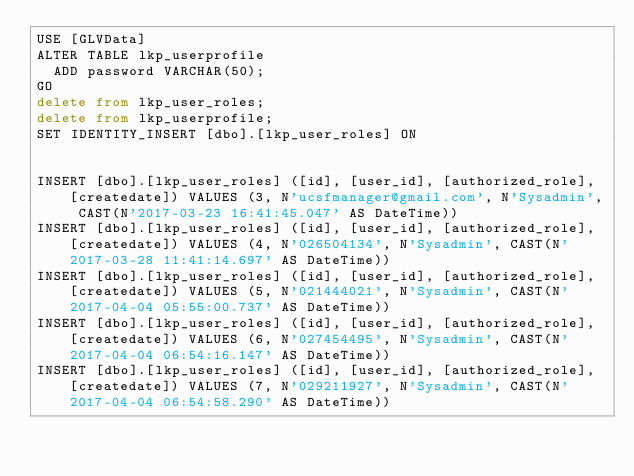<code> <loc_0><loc_0><loc_500><loc_500><_SQL_>USE [GLVData]
ALTER TABLE lkp_userprofile
  ADD password VARCHAR(50);
GO
delete from lkp_user_roles;
delete from lkp_userprofile;
SET IDENTITY_INSERT [dbo].[lkp_user_roles] ON 


INSERT [dbo].[lkp_user_roles] ([id], [user_id], [authorized_role], [createdate]) VALUES (3, N'ucsfmanager@gmail.com', N'Sysadmin', CAST(N'2017-03-23 16:41:45.047' AS DateTime))
INSERT [dbo].[lkp_user_roles] ([id], [user_id], [authorized_role], [createdate]) VALUES (4, N'026504134', N'Sysadmin', CAST(N'2017-03-28 11:41:14.697' AS DateTime))
INSERT [dbo].[lkp_user_roles] ([id], [user_id], [authorized_role], [createdate]) VALUES (5, N'021444021', N'Sysadmin', CAST(N'2017-04-04 05:55:00.737' AS DateTime))
INSERT [dbo].[lkp_user_roles] ([id], [user_id], [authorized_role], [createdate]) VALUES (6, N'027454495', N'Sysadmin', CAST(N'2017-04-04 06:54:16.147' AS DateTime))
INSERT [dbo].[lkp_user_roles] ([id], [user_id], [authorized_role], [createdate]) VALUES (7, N'029211927', N'Sysadmin', CAST(N'2017-04-04 06:54:58.290' AS DateTime))</code> 